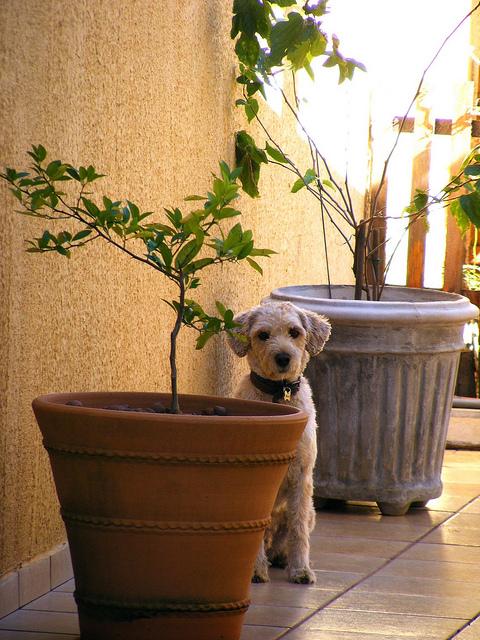What is planted in the planter?
Short answer required. Tree. Is the puppy hiding his favorite toy behind the planter?
Short answer required. No. What type of dog is in the photo?
Short answer required. Schnauzer. 